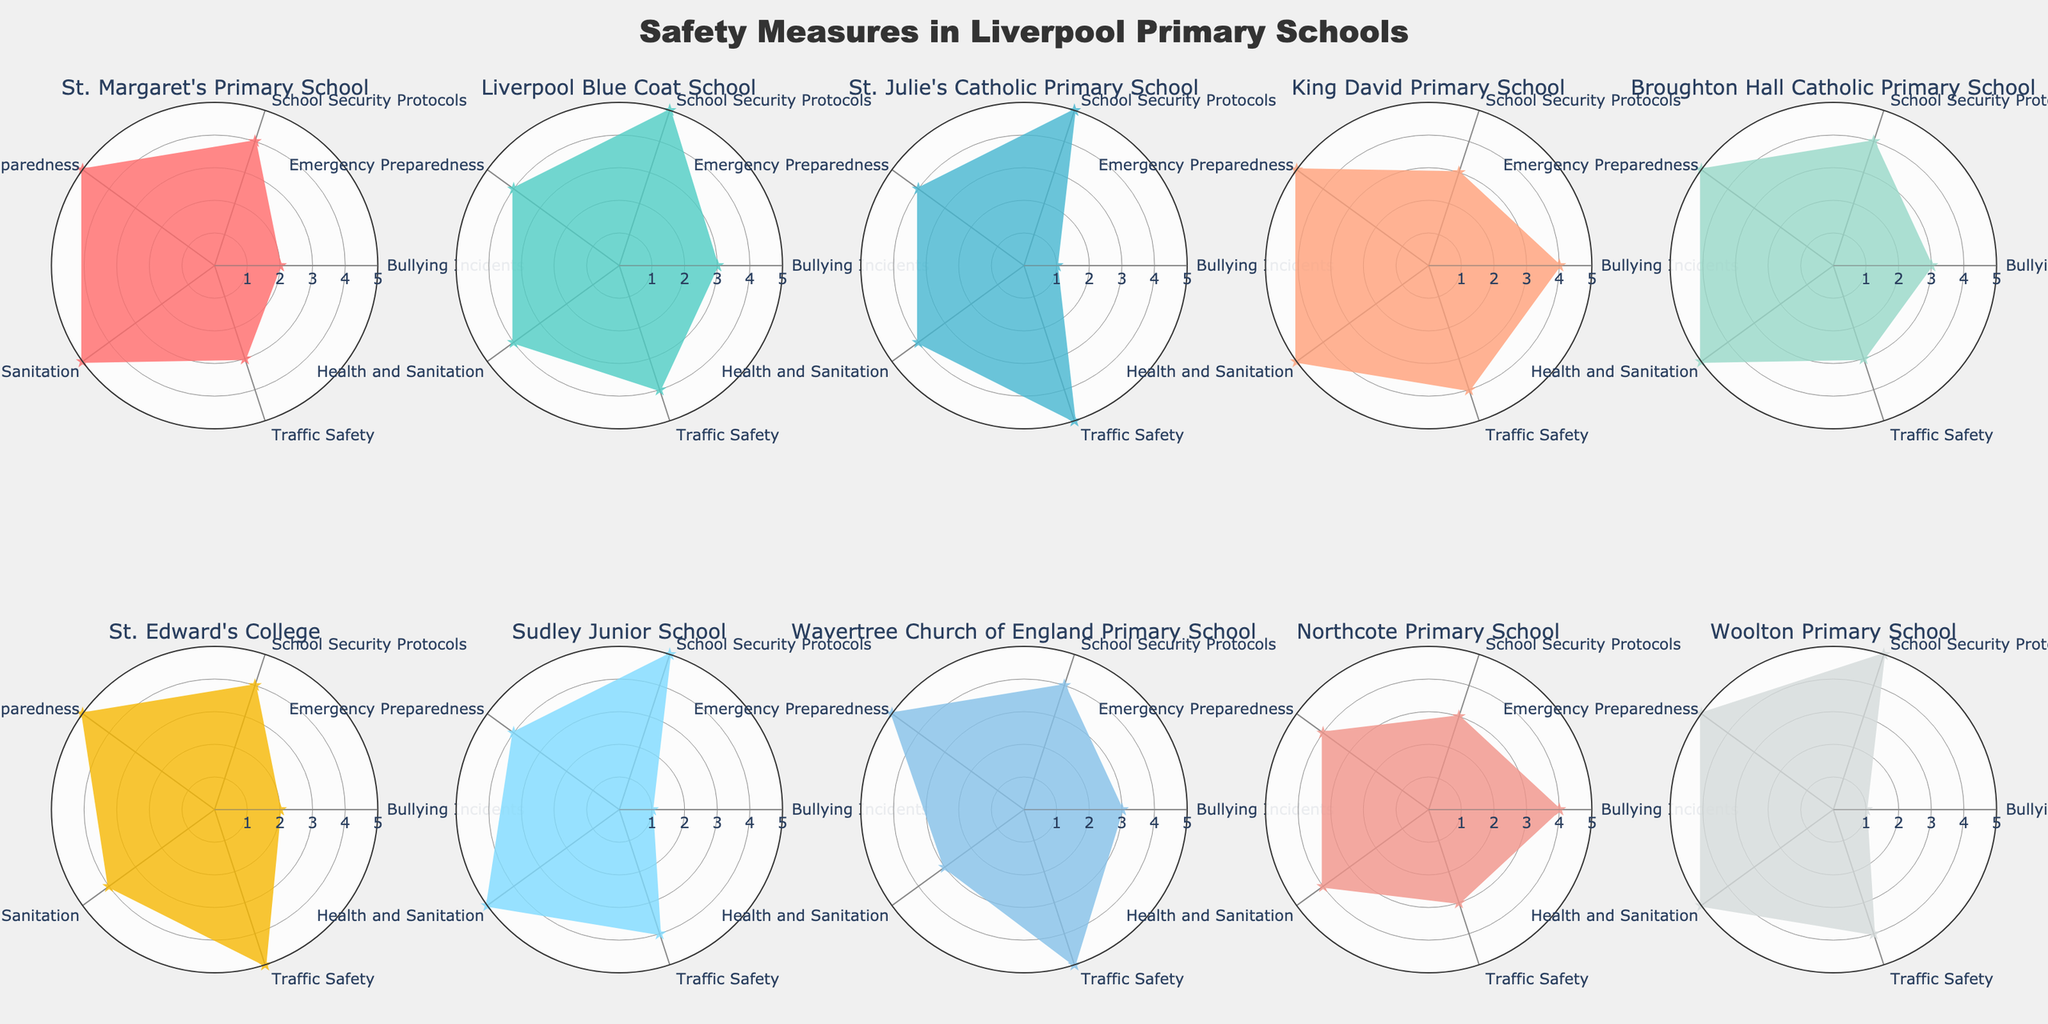which school has the lowest number of bullying incidents? Find the subplot with the innermost value for the "Bullying Incidents" category (closer to the center of the chart indicates a lower number). St. Julie's Catholic Primary School, Sudley Junior School, and Woolton Primary School all show an innermost value for this measure (1).
Answer: St. Julie's Catholic Primary School, Sudley Junior School, Woolton Primary School which school shows the highest score for school security protocols? Identify the subplot with the highest value on the "School Security Protocols" category (closer to the perimeter of the chart indicates a higher score). Liverpool Blue Coat School, St. Julie's Catholic Primary School, Sudley Junior School, and Woolton Primary School all display this category with the value 5.
Answer: Liverpool Blue Coat School, St. Julie's Catholic Primary School, Sudley Junior School, Woolton Primary School between King David Primary School and Northcote Primary School, which one has better emergency preparedness and why? Compare the values of the "Emergency Preparedness" category in the subplots for both schools. King David Primary School shows a value of 5, while Northcote Primary School shows a value of 4. Hence, King David has better emergency preparedness because it has a higher score.
Answer: King David Primary School how does Wavertree Church of England Primary School fare in health and sanitation compared to other schools? Observe the value in the "Health and Sanitation" category for Wavertree Church of England Primary School and compare this with other values in the same category across all subplots. Wavertree shows a value of 3, which is lower than most others with values of 4 or 5. This indicates that Wavertree fares poorer in health and sanitation compared to most other schools.
Answer: Poorer than most what is the average traffic safety score of all the schools? Sum the values of the "Traffic Safety" category across all subplots and divide by the number of schools (10). The scores are 3, 4, 5, 4, 3, 5, 4, 5, 3, 4. Adding these gives 40. Dividing by 10, the average traffic safety score is 4.
Answer: 4 which school is performing equally well in both health and sanitation and emergency preparedness? Look for schools where the values for both "Health and Sanitation" and "Emergency Preparedness" are the same. St. Edward's College has a 4 in both categories, and Northcote Primary School has a 4 in both categories. Woolton Primary School has a 5 in both.
Answer: Woolton Primary School which school displays the most balanced performance across all safety measures (least variability)? Identify the subplot with the most even coverage across all categories. This requires comparing the spread of values across all categories for each school. Woolton Primary School displays consistent scores of 5 across all categories except one (4 in Traffic Safety), indicating a balanced performance.
Answer: Woolton Primary School if you had to choose based solely on lowest average incident of bullying and highest traffic safety, which school would it be? Calculate the average of "Bullying Incidents" and "Traffic Safety" values for each school. St. Julie's Catholic Primary School shows a bullying score of 1 and traffic safety of 5, averaging to (1+5)/2 = 3. Sudley Junior School and Woolton Primary School also show same values but for the lowest average combination, considering only incidents and traffic, St. Julie's takes the balanced choice for lowest variance being overall safe on fewer incidents alongside traffic safety.
Answer: St. Julie's Catholic Primary School by comparing the emergency preparedness and school security protocols, which school might require the most improvement? Compare the lowest values within the "Emergency Preparedness" and "School Security Protocols" categories across all subplots. Northcote Primary School and King David Primary School show lower values (3 in School Security and 4 in Emergency Preparedness). Given this dual category evaluation, Northcote will have overall lower combined scores in critical measures, suggesting a need for enhancement.
Answer: Northcote Primary School 